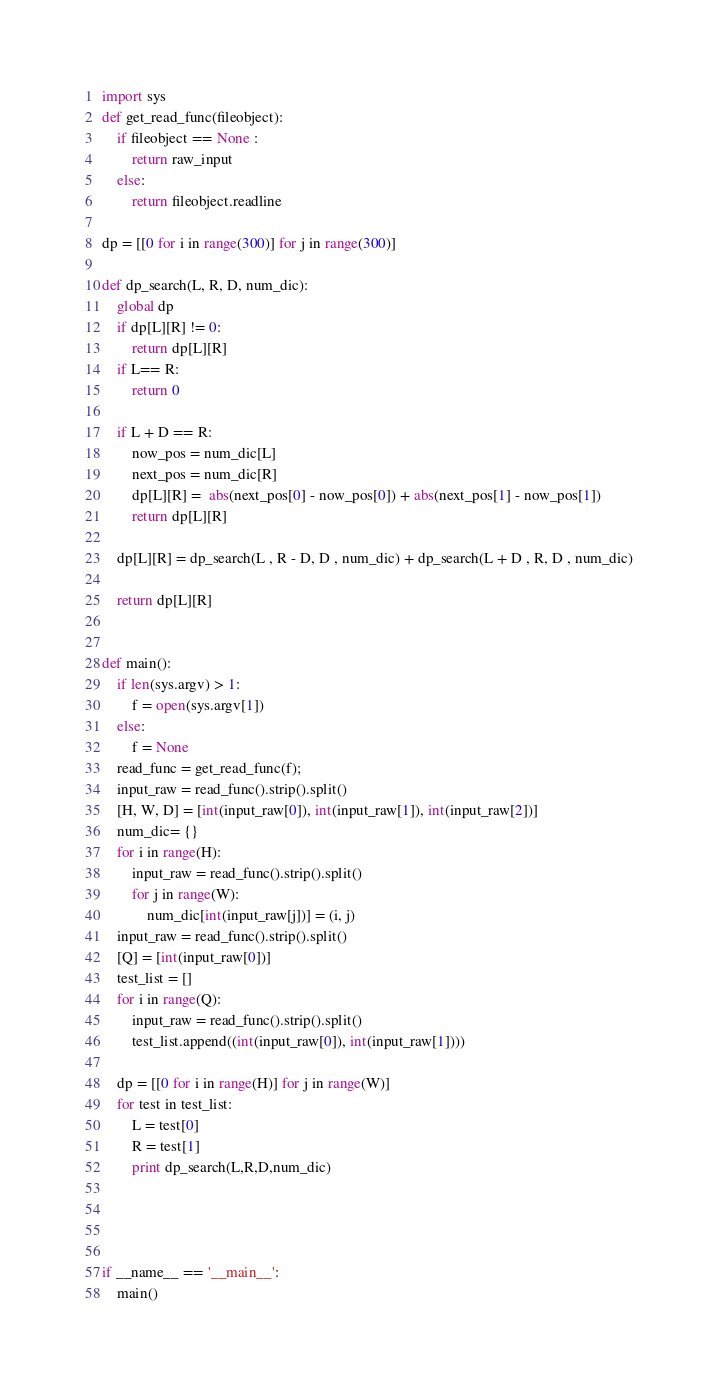Convert code to text. <code><loc_0><loc_0><loc_500><loc_500><_Python_>import sys
def get_read_func(fileobject):
    if fileobject == None :
        return raw_input
    else:
        return fileobject.readline

dp = [[0 for i in range(300)] for j in range(300)]

def dp_search(L, R, D, num_dic):
    global dp
    if dp[L][R] != 0:
        return dp[L][R]
    if L== R:
        return 0

    if L + D == R:
        now_pos = num_dic[L]
        next_pos = num_dic[R]
        dp[L][R] =  abs(next_pos[0] - now_pos[0]) + abs(next_pos[1] - now_pos[1])
        return dp[L][R]

    dp[L][R] = dp_search(L , R - D, D , num_dic) + dp_search(L + D , R, D , num_dic)

    return dp[L][R]


def main():
    if len(sys.argv) > 1:
        f = open(sys.argv[1])
    else:
        f = None
    read_func = get_read_func(f);
    input_raw = read_func().strip().split()
    [H, W, D] = [int(input_raw[0]), int(input_raw[1]), int(input_raw[2])]
    num_dic= {}
    for i in range(H):
        input_raw = read_func().strip().split()
        for j in range(W):
            num_dic[int(input_raw[j])] = (i, j)
    input_raw = read_func().strip().split()
    [Q] = [int(input_raw[0])]
    test_list = []
    for i in range(Q):
        input_raw = read_func().strip().split()
        test_list.append((int(input_raw[0]), int(input_raw[1])))

    dp = [[0 for i in range(H)] for j in range(W)]
    for test in test_list:
        L = test[0]
        R = test[1]
        print dp_search(L,R,D,num_dic)




if __name__ == '__main__':
    main()</code> 